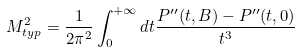<formula> <loc_0><loc_0><loc_500><loc_500>M ^ { 2 } _ { t y p } = \frac { 1 } { 2 \pi ^ { 2 } } \int _ { 0 } ^ { + \infty } d t \frac { P ^ { \prime \prime } ( t , B ) - P ^ { \prime \prime } ( t , 0 ) } { t ^ { 3 } }</formula> 